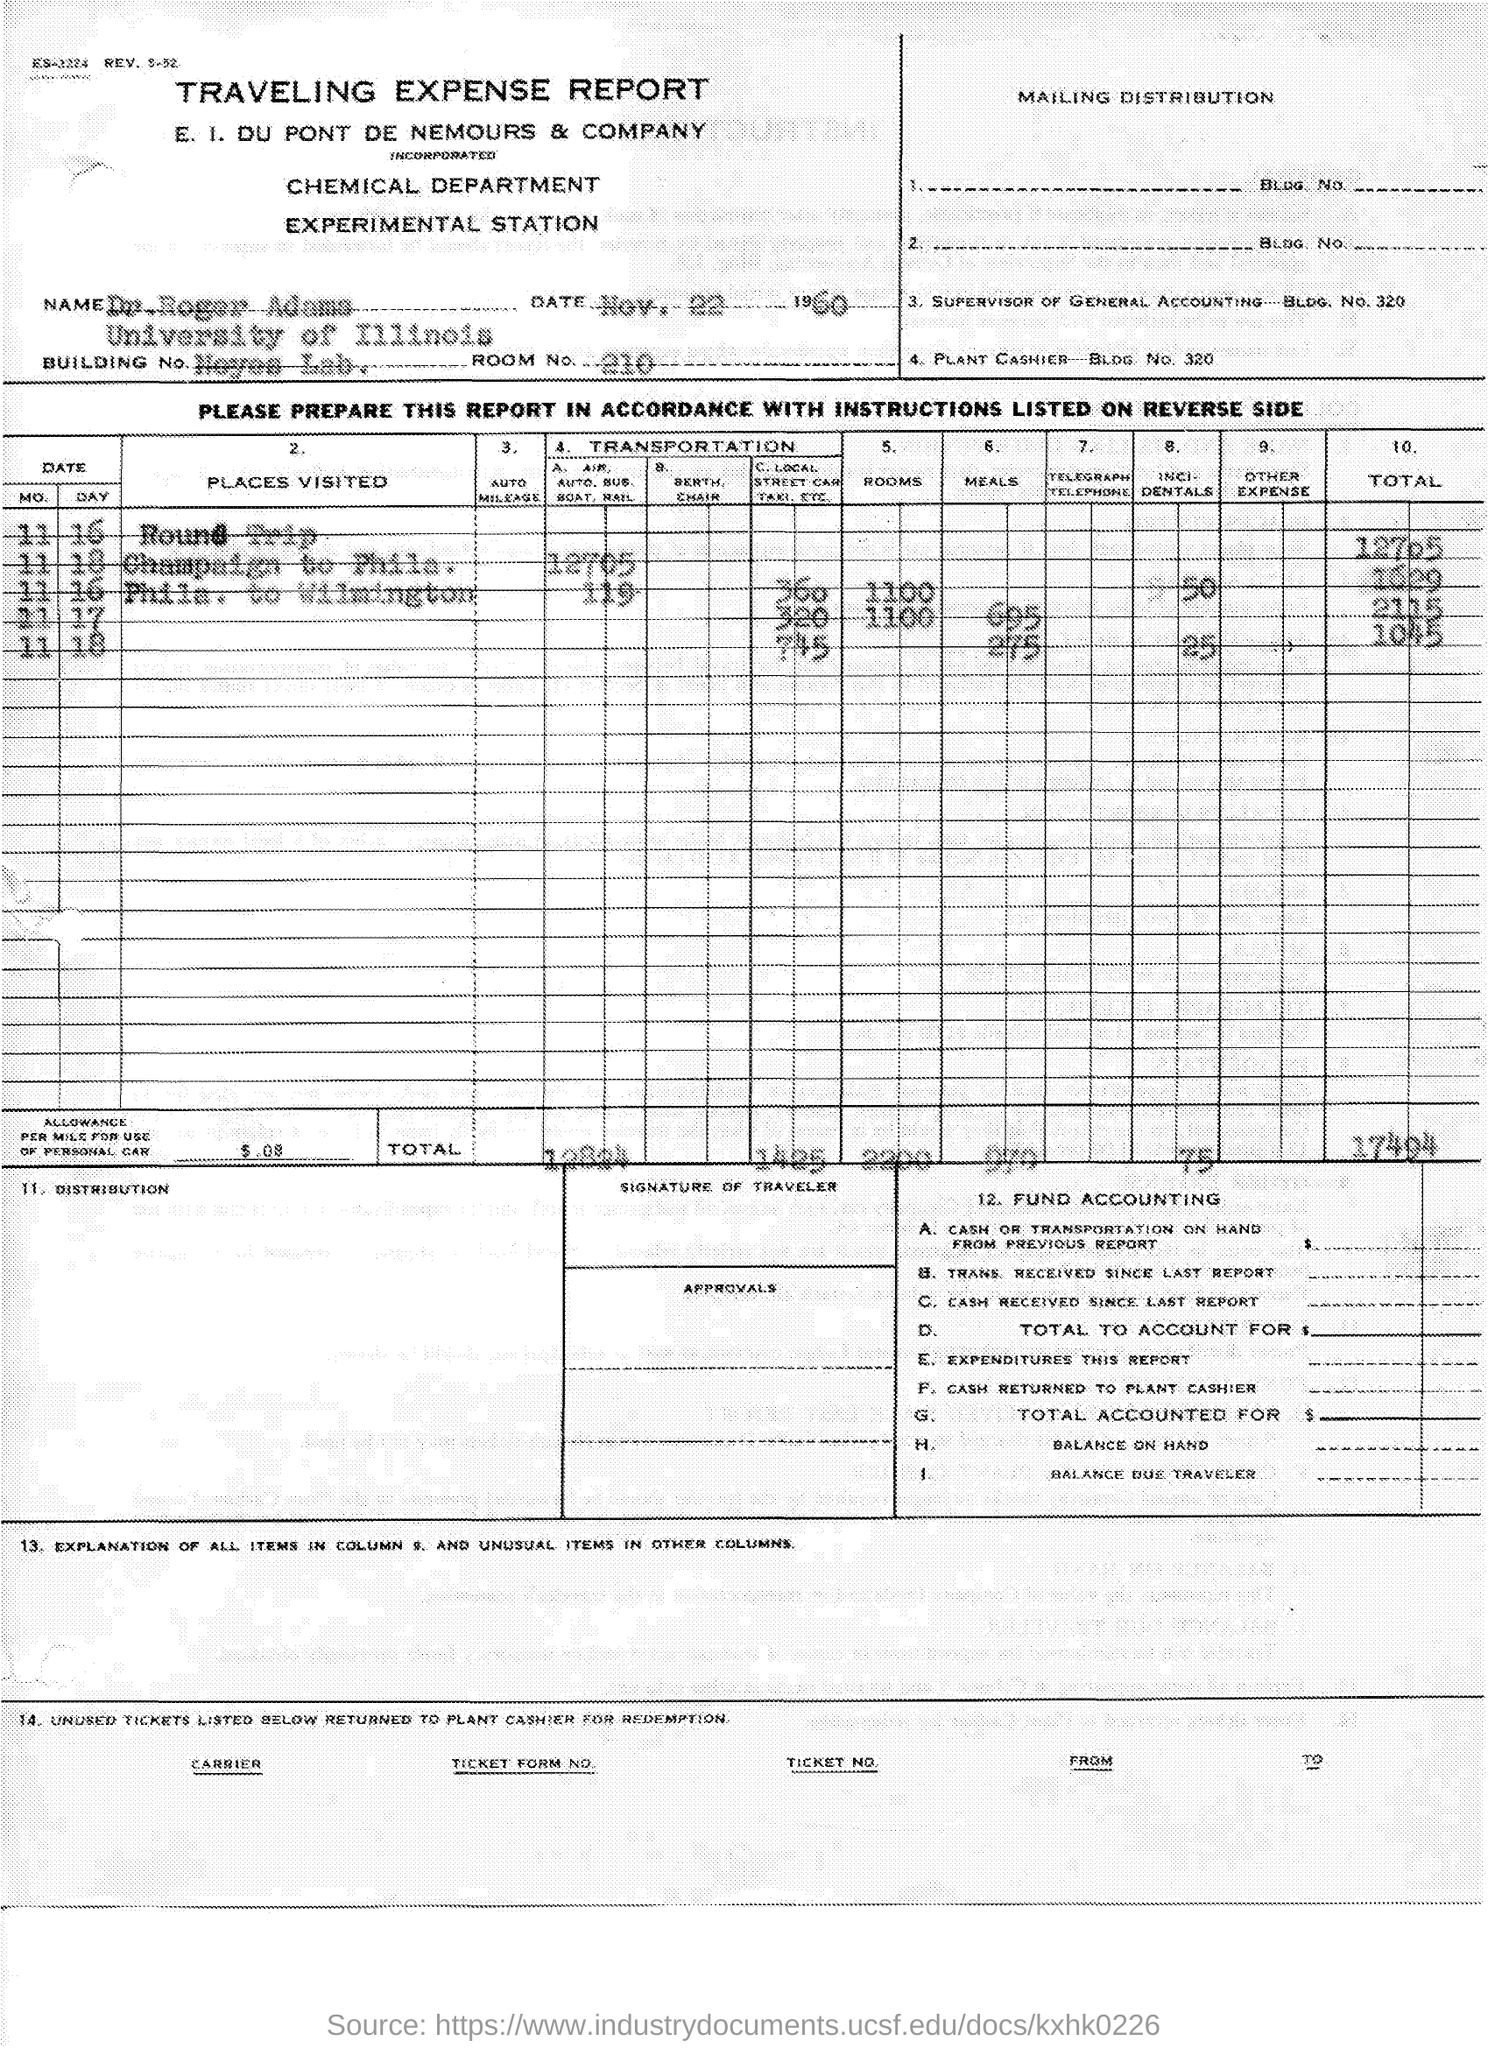What is the name of the given report ?
Give a very brief answer. TRAVELING EXPENSE. What is the name of the department mentioned in the given report ?
Offer a terse response. Chemical department. What is the date mentioned in the given report ?
Provide a short and direct response. Nov. 22 1960. What is the room no. mentioned in the given report ?
Make the answer very short. 210. What is the name mentioned in the given report ?
Make the answer very short. Dr. Roger Adams. What is the name of the university mentioned in the given report ?
Make the answer very short. University of Illinois. What is the building no. mentioned in the given report ?
Ensure brevity in your answer.  Neyes Lab. What is the amount of allowance given per mile for use of personal car mentioned in the given report ?
Ensure brevity in your answer.  .08. 